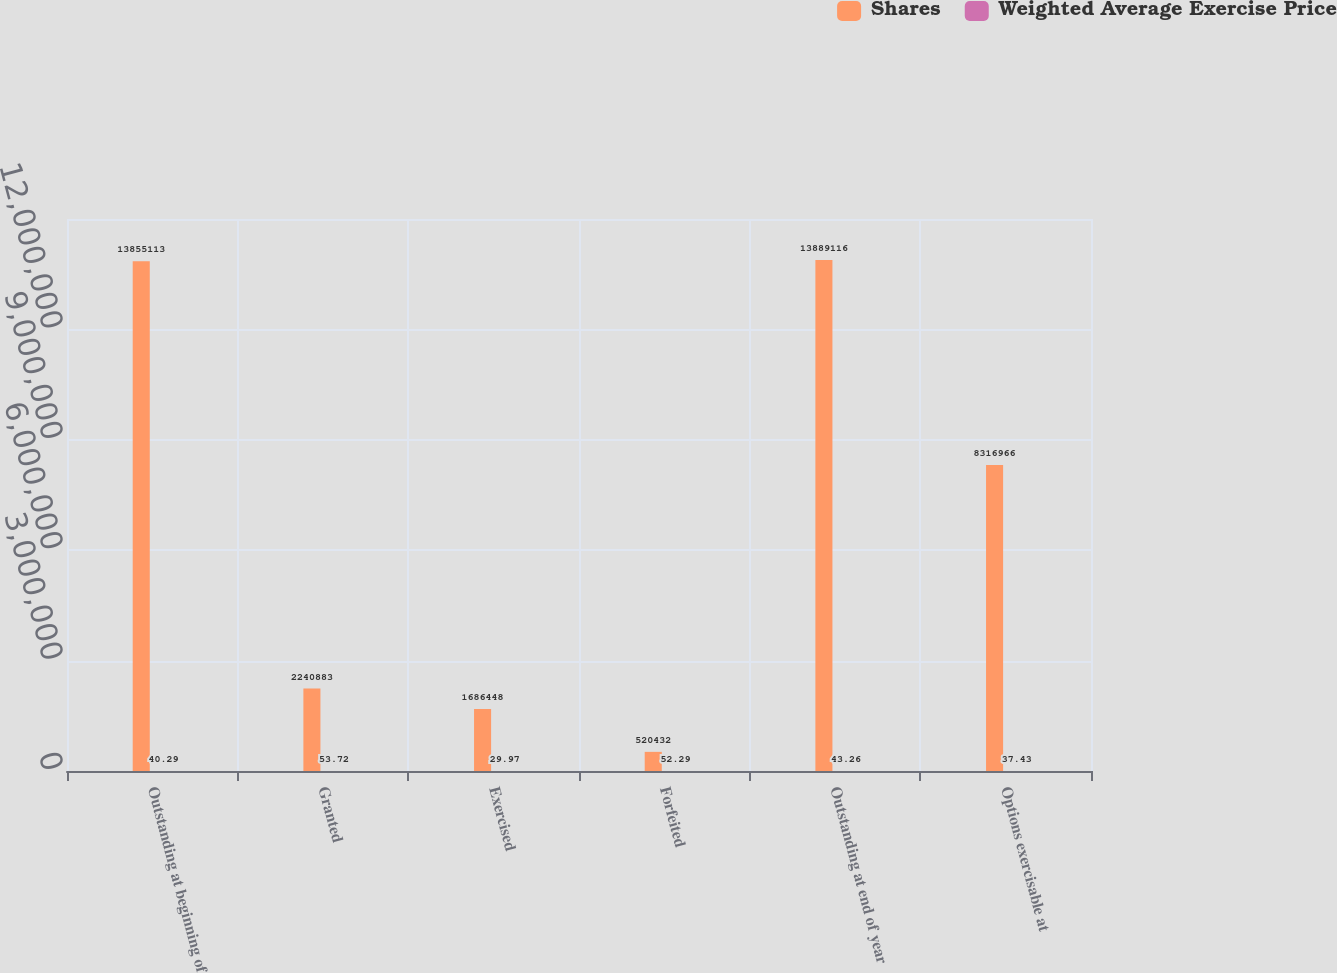<chart> <loc_0><loc_0><loc_500><loc_500><stacked_bar_chart><ecel><fcel>Outstanding at beginning of<fcel>Granted<fcel>Exercised<fcel>Forfeited<fcel>Outstanding at end of year<fcel>Options exercisable at<nl><fcel>Shares<fcel>1.38551e+07<fcel>2.24088e+06<fcel>1.68645e+06<fcel>520432<fcel>1.38891e+07<fcel>8.31697e+06<nl><fcel>Weighted Average Exercise Price<fcel>40.29<fcel>53.72<fcel>29.97<fcel>52.29<fcel>43.26<fcel>37.43<nl></chart> 